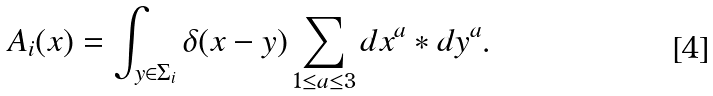<formula> <loc_0><loc_0><loc_500><loc_500>A _ { i } ( x ) = \int _ { y \in \Sigma _ { i } } \delta ( x - y ) \sum _ { 1 \leq a \leq 3 } d x ^ { a } * d y ^ { a } .</formula> 